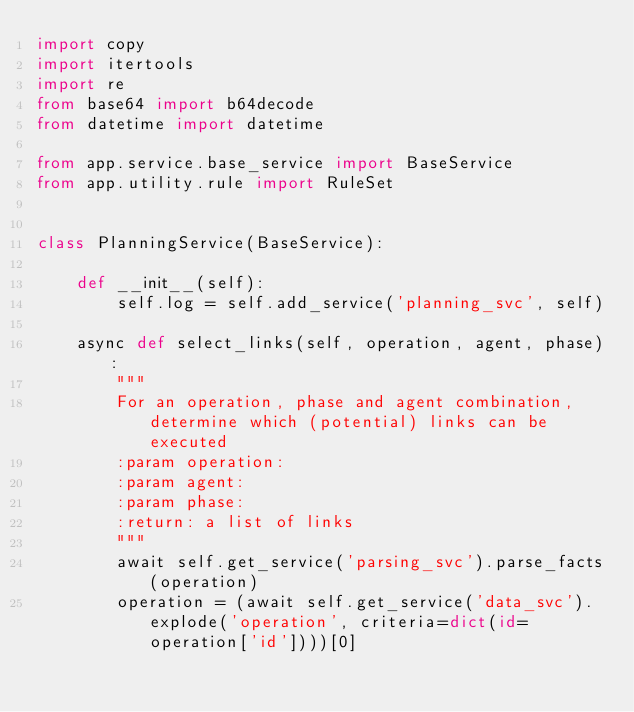<code> <loc_0><loc_0><loc_500><loc_500><_Python_>import copy
import itertools
import re
from base64 import b64decode
from datetime import datetime

from app.service.base_service import BaseService
from app.utility.rule import RuleSet


class PlanningService(BaseService):

    def __init__(self):
        self.log = self.add_service('planning_svc', self)

    async def select_links(self, operation, agent, phase):
        """
        For an operation, phase and agent combination, determine which (potential) links can be executed
        :param operation:
        :param agent:
        :param phase:
        :return: a list of links
        """
        await self.get_service('parsing_svc').parse_facts(operation)
        operation = (await self.get_service('data_svc').explode('operation', criteria=dict(id=operation['id'])))[0]
</code> 